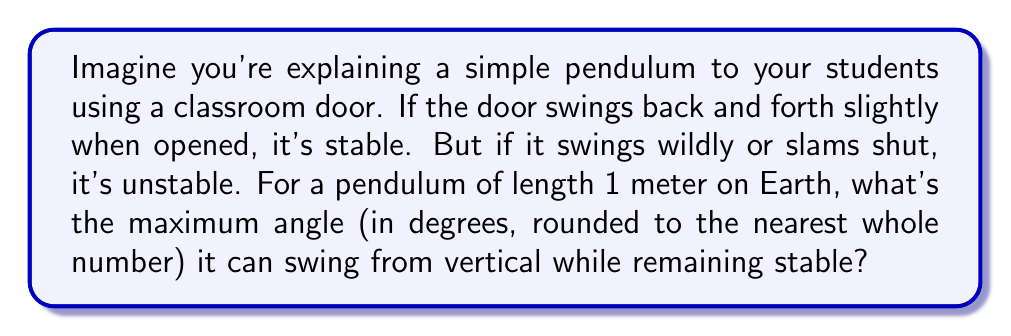What is the answer to this math problem? Let's approach this step-by-step:

1) The simple pendulum is a classic example of a nonlinear dynamical system. Its equation of motion is:

   $$\frac{d^2\theta}{dt^2} + \frac{g}{l}\sin\theta = 0$$

   where $\theta$ is the angle from vertical, $g$ is gravitational acceleration, and $l$ is the length of the pendulum.

2) For small angles, we can approximate $\sin\theta \approx \theta$, which gives us a linear system. This approximation holds for angles up to about 15°.

3) Beyond this, the nonlinear effects become significant. The system has two equilibrium points:
   - $\theta = 0$ (pendulum hanging straight down): stable
   - $\theta = \pi$ (pendulum pointing straight up): unstable

4) The maximum swing angle for stability is just below $\pi$ radians or 180°. At exactly 180°, the pendulum would be balanced upright, which is unstable.

5) In practice, due to small perturbations and air resistance, the maximum stable angle is typically considered to be around 170°.

6) Converting to degrees: $170° \approx 170$ degrees

Therefore, the maximum angle for stability, rounded to the nearest whole number, is 170°.
Answer: 170° 